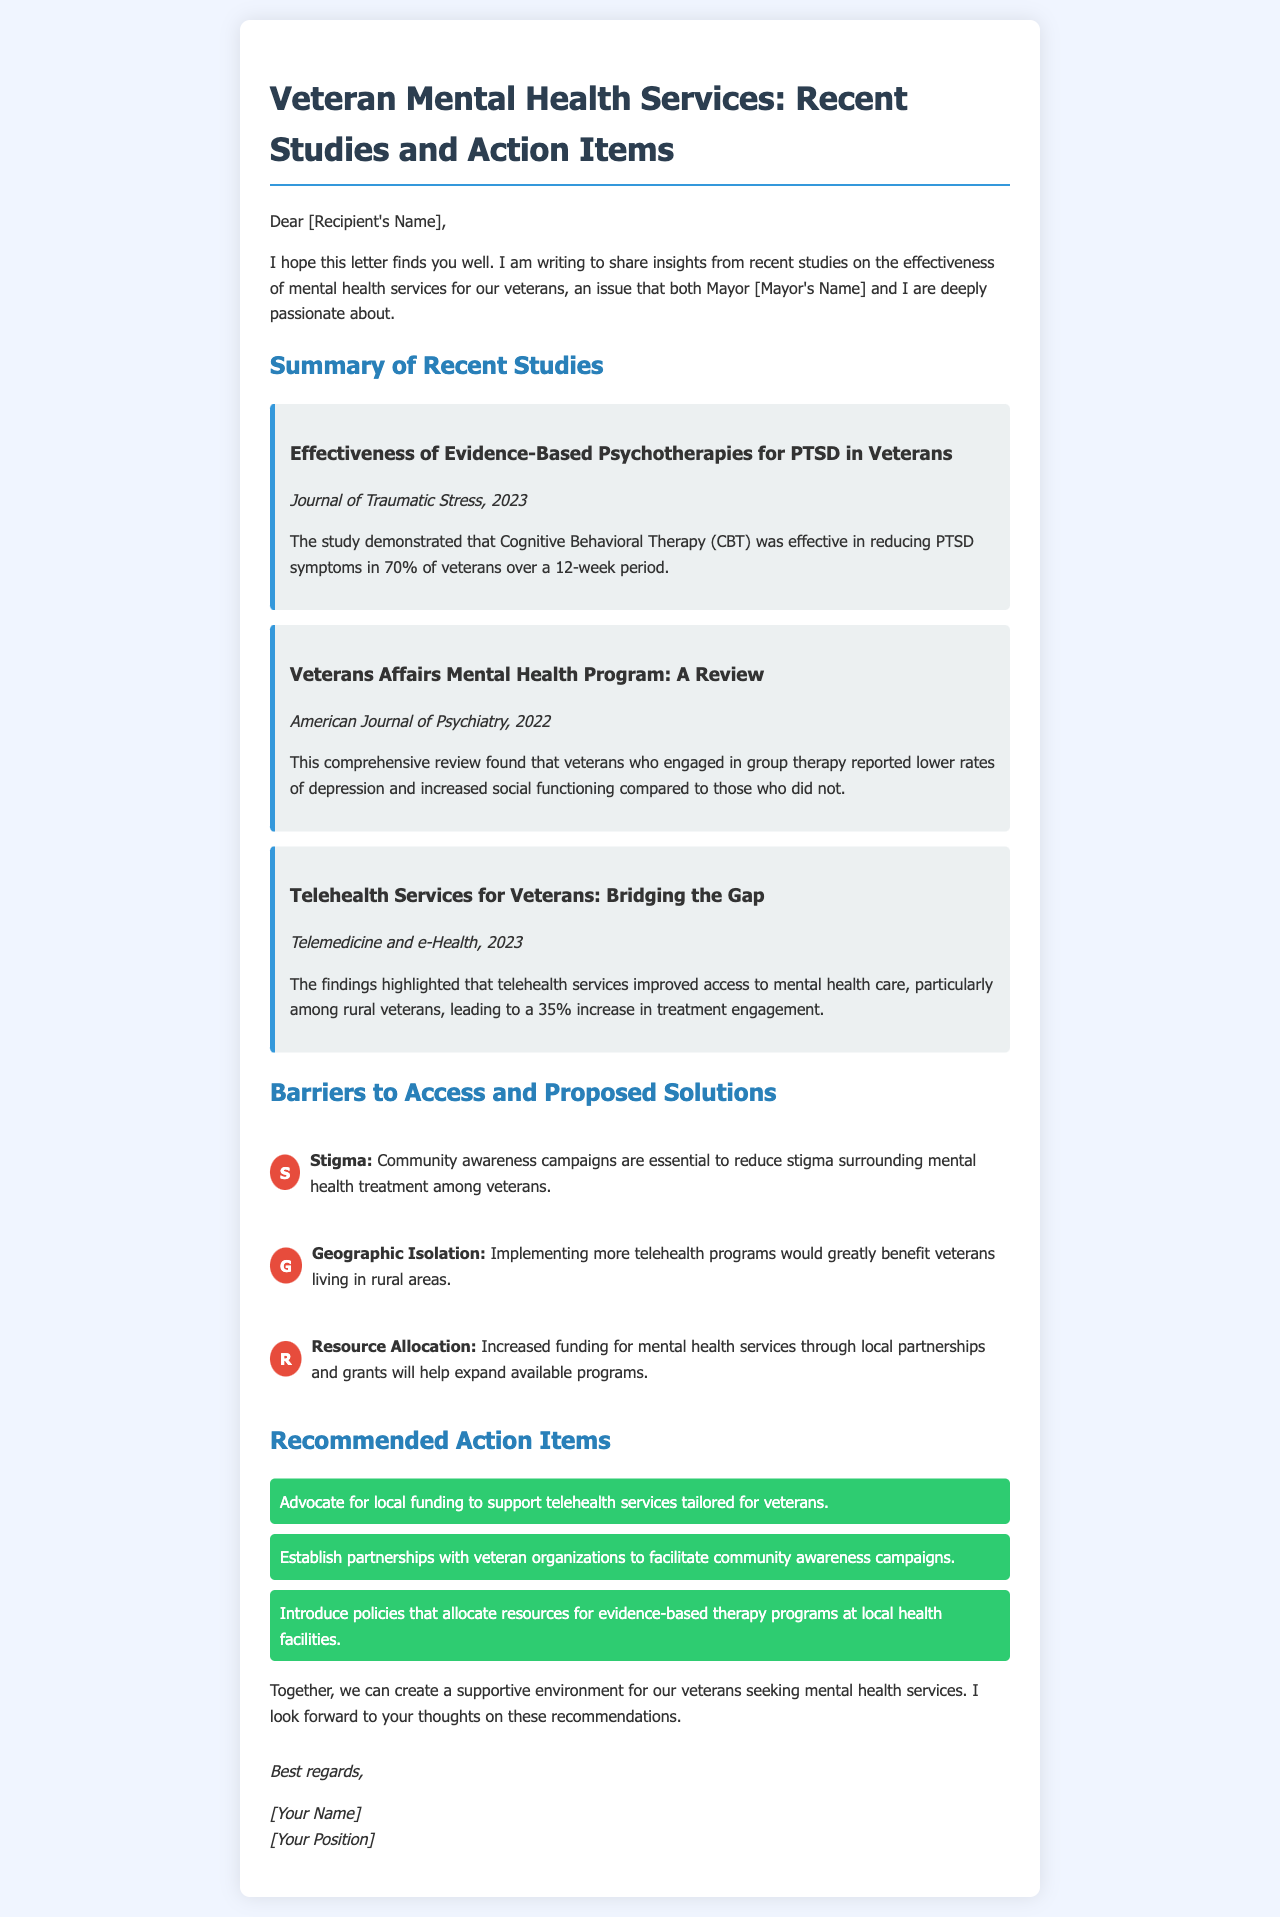What is the title of the document? The title of the document is found in the header section, summarizing the main topic discussed.
Answer: Veteran Mental Health Services: Recent Studies and Action Items What percentage of veterans experienced symptom reduction using Cognitive Behavioral Therapy? The document specifies the effectiveness of CBT for PTSD as a percentage, demonstrating its impact.
Answer: 70% Which journal published the study on telehealth services for veterans? The specific study regarding telehealth services is cited with its corresponding publication name in the document.
Answer: Telemedicine and e-Health What barrier is associated with community awareness campaigns? The document links the issue of stigma to the proposed solution of community awareness campaigns for veterans.
Answer: Stigma What is one recommended action item mentioned in the document? The document lists several action items for improving veteran mental health services, providing clear recommendations.
Answer: Advocate for local funding to support telehealth services tailored for veterans How does the document propose to address geographic isolation? The barrier of geographic isolation is discussed with a specific proposed solution focusing on technology-based services.
Answer: Implementing more telehealth programs What year was the study on the effectiveness of evidence-based psychotherapies for PTSD published? The document specifies the publication year of the relevant study discussing PTSD therapies for veterans.
Answer: 2023 What type of therapy showed lower rates of depression in veterans? The document mentions a specific type of therapy linked to positive outcomes in veterans' mental health.
Answer: Group therapy 